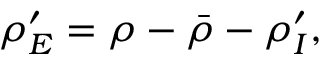<formula> <loc_0><loc_0><loc_500><loc_500>{ \rho } _ { E } ^ { \prime } = \rho - \bar { \rho } - { \rho } _ { I } ^ { \prime } ,</formula> 